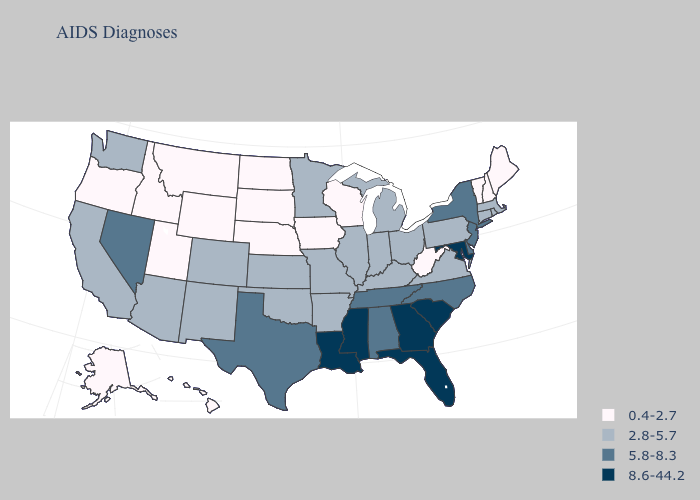What is the value of North Carolina?
Give a very brief answer. 5.8-8.3. Which states hav the highest value in the MidWest?
Be succinct. Illinois, Indiana, Kansas, Michigan, Minnesota, Missouri, Ohio. Among the states that border Tennessee , does Arkansas have the highest value?
Write a very short answer. No. What is the value of Nevada?
Short answer required. 5.8-8.3. Which states hav the highest value in the West?
Be succinct. Nevada. Name the states that have a value in the range 0.4-2.7?
Answer briefly. Alaska, Hawaii, Idaho, Iowa, Maine, Montana, Nebraska, New Hampshire, North Dakota, Oregon, South Dakota, Utah, Vermont, West Virginia, Wisconsin, Wyoming. How many symbols are there in the legend?
Give a very brief answer. 4. Name the states that have a value in the range 8.6-44.2?
Write a very short answer. Florida, Georgia, Louisiana, Maryland, Mississippi, South Carolina. Which states have the highest value in the USA?
Be succinct. Florida, Georgia, Louisiana, Maryland, Mississippi, South Carolina. Name the states that have a value in the range 8.6-44.2?
Be succinct. Florida, Georgia, Louisiana, Maryland, Mississippi, South Carolina. What is the lowest value in states that border Arizona?
Concise answer only. 0.4-2.7. Name the states that have a value in the range 2.8-5.7?
Quick response, please. Arizona, Arkansas, California, Colorado, Connecticut, Illinois, Indiana, Kansas, Kentucky, Massachusetts, Michigan, Minnesota, Missouri, New Mexico, Ohio, Oklahoma, Pennsylvania, Rhode Island, Virginia, Washington. Among the states that border Oregon , does Idaho have the lowest value?
Concise answer only. Yes. Name the states that have a value in the range 0.4-2.7?
Short answer required. Alaska, Hawaii, Idaho, Iowa, Maine, Montana, Nebraska, New Hampshire, North Dakota, Oregon, South Dakota, Utah, Vermont, West Virginia, Wisconsin, Wyoming. Name the states that have a value in the range 8.6-44.2?
Give a very brief answer. Florida, Georgia, Louisiana, Maryland, Mississippi, South Carolina. 